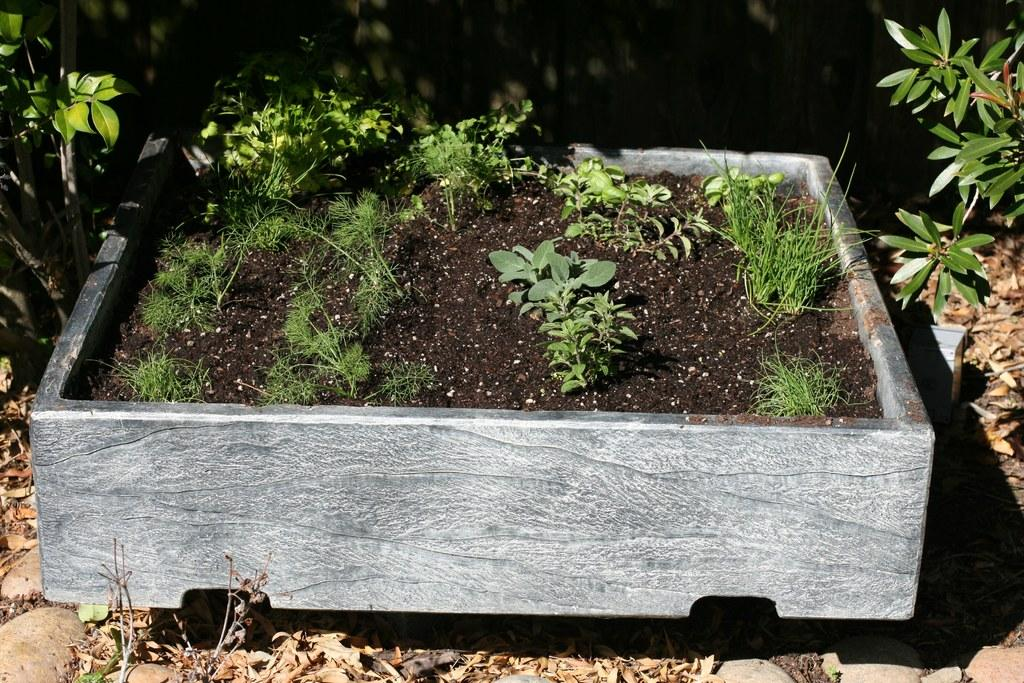What is in the pot that is visible in the image? There are tiny plants in a pot in the image. What else can be seen in the image besides the pot with tiny plants? There are plants in the background of the image. What type of thrill can be seen in the image? There is no thrill present in the image; it features plants in a pot and in the background. Can you tell me how many pins are visible in the image? There are no pins present in the image. 